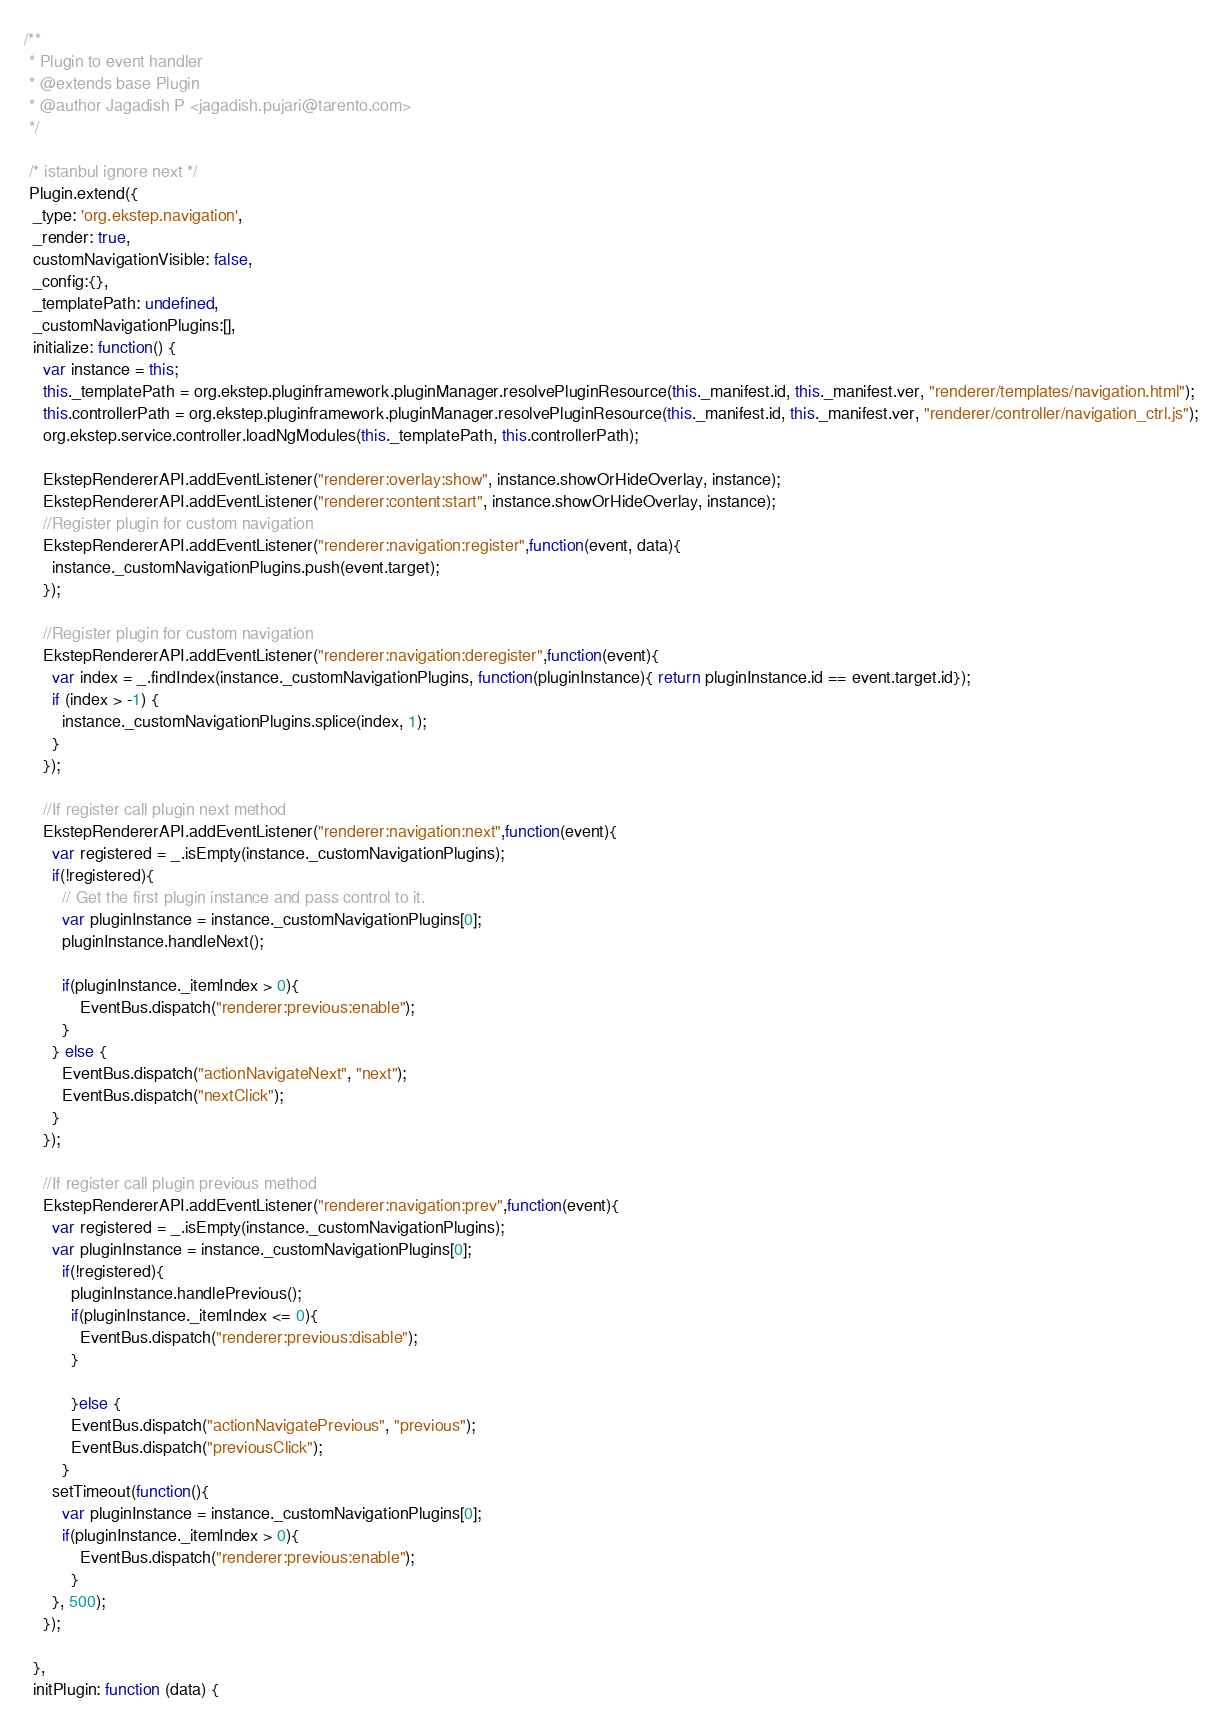<code> <loc_0><loc_0><loc_500><loc_500><_JavaScript_>/**
 * Plugin to event handler
 * @extends base Plugin
 * @author Jagadish P <jagadish.pujari@tarento.com>
 */

 /* istanbul ignore next */
 Plugin.extend({
  _type: 'org.ekstep.navigation',
  _render: true, 
  customNavigationVisible: false, 
  _config:{},
  _templatePath: undefined,
  _customNavigationPlugins:[],
  initialize: function() {
    var instance = this;
    this._templatePath = org.ekstep.pluginframework.pluginManager.resolvePluginResource(this._manifest.id, this._manifest.ver, "renderer/templates/navigation.html");
    this.controllerPath = org.ekstep.pluginframework.pluginManager.resolvePluginResource(this._manifest.id, this._manifest.ver, "renderer/controller/navigation_ctrl.js");
    org.ekstep.service.controller.loadNgModules(this._templatePath, this.controllerPath);

    EkstepRendererAPI.addEventListener("renderer:overlay:show", instance.showOrHideOverlay, instance);        
    EkstepRendererAPI.addEventListener("renderer:content:start", instance.showOrHideOverlay, instance);
    //Register plugin for custom navigation
    EkstepRendererAPI.addEventListener("renderer:navigation:register",function(event, data){
      instance._customNavigationPlugins.push(event.target);
    });

    //Register plugin for custom navigation
    EkstepRendererAPI.addEventListener("renderer:navigation:deregister",function(event){
      var index = _.findIndex(instance._customNavigationPlugins, function(pluginInstance){ return pluginInstance.id == event.target.id});
      if (index > -1) {
        instance._customNavigationPlugins.splice(index, 1);
      }
    });

    //If register call plugin next method
    EkstepRendererAPI.addEventListener("renderer:navigation:next",function(event){
      var registered = _.isEmpty(instance._customNavigationPlugins);
      if(!registered){
        // Get the first plugin instance and pass control to it.
        var pluginInstance = instance._customNavigationPlugins[0];
        pluginInstance.handleNext();

        if(pluginInstance._itemIndex > 0){
            EventBus.dispatch("renderer:previous:enable");
        }
      } else {
        EventBus.dispatch("actionNavigateNext", "next");
        EventBus.dispatch("nextClick");
      }
    });

    //If register call plugin previous method
    EkstepRendererAPI.addEventListener("renderer:navigation:prev",function(event){
      var registered = _.isEmpty(instance._customNavigationPlugins);
      var pluginInstance = instance._customNavigationPlugins[0];
        if(!registered){
          pluginInstance.handlePrevious();
          if(pluginInstance._itemIndex <= 0){
            EventBus.dispatch("renderer:previous:disable");
          }
        
          }else {
          EventBus.dispatch("actionNavigatePrevious", "previous");
          EventBus.dispatch("previousClick");
        }
      setTimeout(function(){ 
        var pluginInstance = instance._customNavigationPlugins[0];
        if(pluginInstance._itemIndex > 0){
            EventBus.dispatch("renderer:previous:enable");
          }
      }, 500);
    });

  },
  initPlugin: function (data) {</code> 